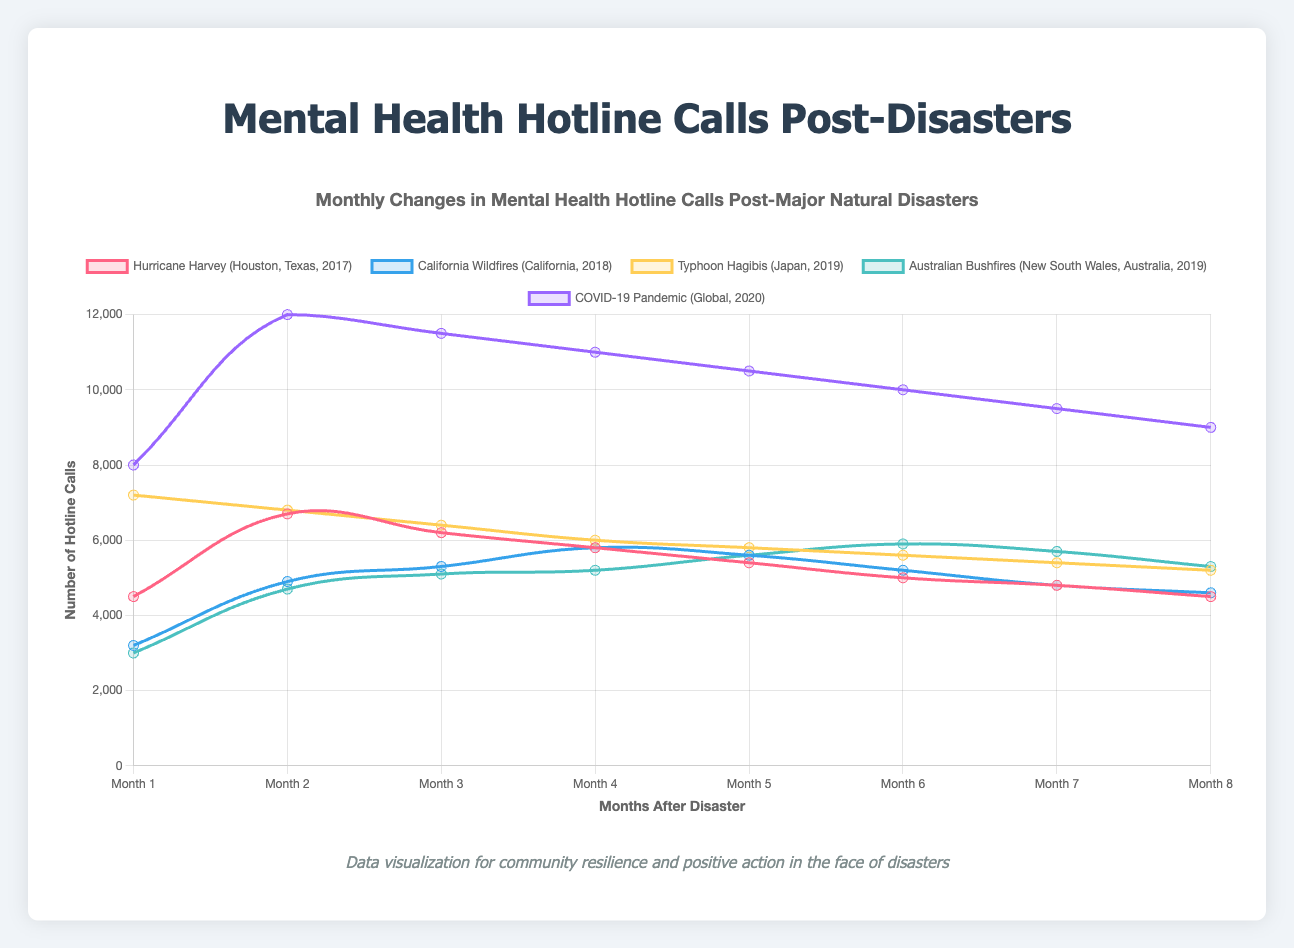What's the highest number of calls received in any month for the COVID-19 pandemic? The line representing the COVID-19 pandemic shows the peak in April with 12,000 calls.
Answer: 12,000 Which disaster had the lowest number of calls in any month, and how many calls were there? The Australian Bushfires in September had the lowest number of calls with 3,000.
Answer: Australian Bushfires, 3,000 Compare the initial spike in hotline calls for Hurricane Harvey and Typhoon Hagibis. Which was higher and by how much? Hurricane Harvey started with 4,500 calls in August and peaked at 6,700 in September, whereas Typhoon Hagibis immediately peaked in October at 7,200. So, Typhoon Hagibis was higher by 500 calls.
Answer: Typhoon Hagibis, 500 What is the average monthly calls for the California Wildfires over the eight months shown? To find the average, sum up all the monthly calls for California Wildfires (3,200 + 4,900 + 5,300 + 5,800 + 5,600 + 5,200 + 4,800 + 4,600) = 39,400. Then divide by 8, the number of months: 39,400 / 8 = 4,925.
Answer: 4,925 How many more calls were made during the peak month of the COVID-19 pandemic compared to the peak month of Hurricane Harvey? The peak of the COVID-19 pandemic was 12,000 calls in April, and the peak of Hurricane Harvey was 6,700 calls in September. The difference is 12,000 - 6,700 = 5,300.
Answer: 5,300 During which month did the Australian Bushfires see the highest number of hotline calls, and what was the count? The chart shows that the Australian Bushfires had the highest number of hotline calls in February, with 5,900 calls.
Answer: February, 5,900 How does the trend of hotline calls for Typhoon Hagibis compare with the trend for COVID-19 pandemic in terms of the maximum and minimum calls? Typhoon Hagibis starts at a maximum of 7,200 in October and decreases to a minimum of 5,200 in May. COVID-19 starts at 8,000 in March, peaks at 12,000 in April, and gradually decreases to a minimum of 9,000 by October. COVID-19 has higher initial and peak values compared to Typhoon Hagibis.
Answer: COVID-19 has higher initial and peak values Which disaster had a continuous decrease in hotline calls each month without any peaks? Typhoon Hagibis shows a continuous decrease in hotline calls every month from October onward without any peaks.
Answer: Typhoon Hagibis What is the total number of hotline calls for Hurricane Harvey over the eight months shown? Sum the monthly calls for Hurricane Harvey: 4,500 + 6,700 + 6,200 + 5,800 + 5,400 + 5,000 + 4,800 + 4,500 = 42,900
Answer: 42,900 Which disaster saw the highest rise in calls from one month to the next, and between which months did this occur? The COVID-19 pandemic saw the highest rise from March (8,000) to April (12,000), an increase of 4,000 calls.
Answer: COVID-19 pandemic, March to April 